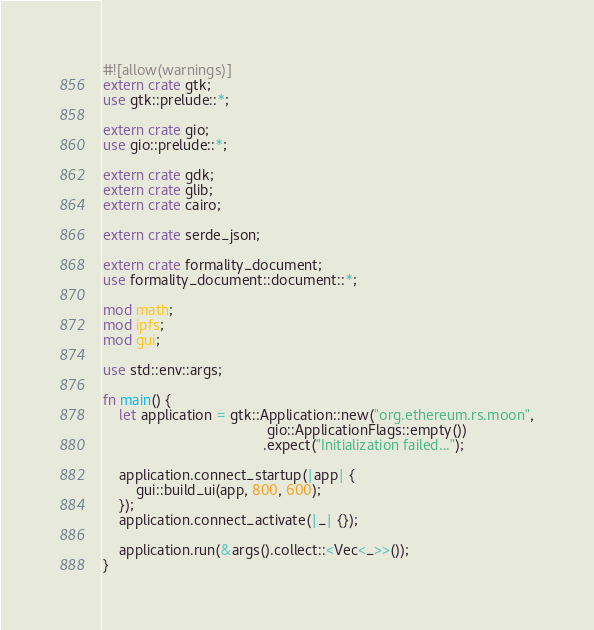Convert code to text. <code><loc_0><loc_0><loc_500><loc_500><_Rust_>#![allow(warnings)]
extern crate gtk;
use gtk::prelude::*;

extern crate gio;
use gio::prelude::*;

extern crate gdk;
extern crate glib;
extern crate cairo;

extern crate serde_json;

extern crate formality_document;
use formality_document::document::*;

mod math;
mod ipfs;
mod gui;

use std::env::args;

fn main() {
    let application = gtk::Application::new("org.ethereum.rs.moon",
                                        gio::ApplicationFlags::empty())
                                       .expect("Initialization failed...");

    application.connect_startup(|app| {
        gui::build_ui(app, 800, 600);
    });
    application.connect_activate(|_| {});

    application.run(&args().collect::<Vec<_>>());
}
</code> 